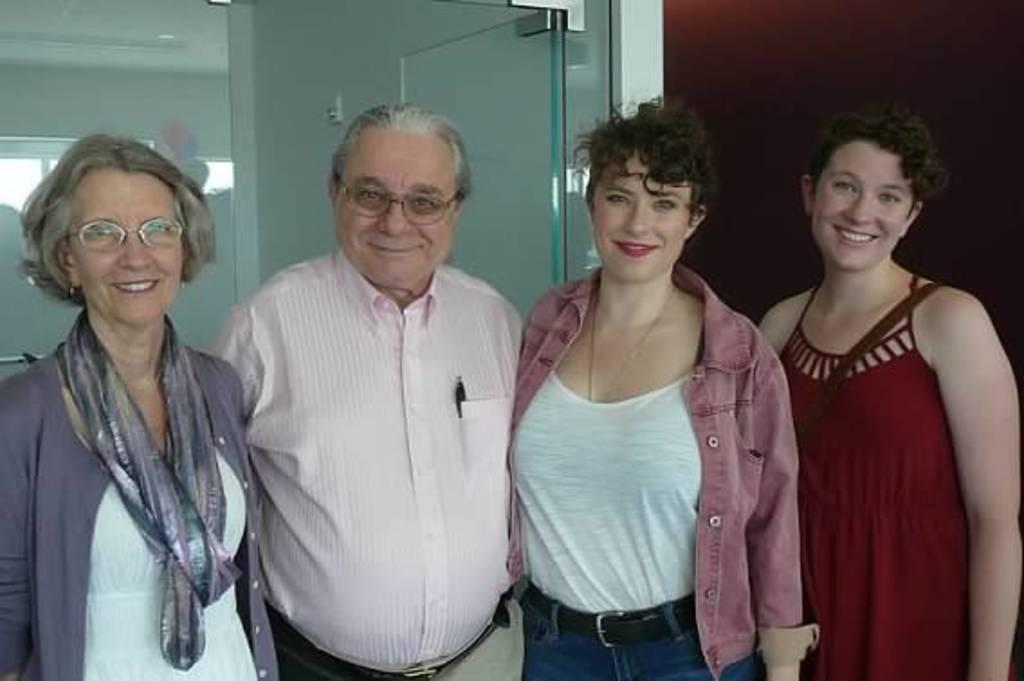How many people are in the image? There is a man and three women in the image. What are the people in the image doing? The man and women are standing and smiling. What can be seen in the background of the image? There is a glass wall and other objects visible in the background. What type of desk can be seen in the image? There is no desk present in the image. Is there a kite flying in the background of the image? There is no kite visible in the image. 